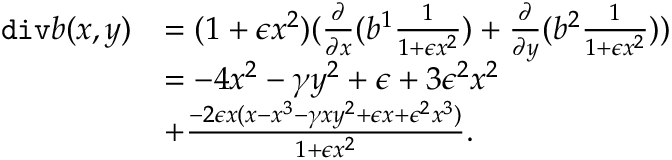Convert formula to latex. <formula><loc_0><loc_0><loc_500><loc_500>\begin{array} { r l } { d i v b ( x , y ) } & { = ( 1 + \epsilon x ^ { 2 } ) ( \frac { \partial } { \partial { x } } ( b ^ { 1 } \frac { 1 } { 1 + \epsilon x ^ { 2 } } ) + \frac { \partial } { \partial { y } } ( b ^ { 2 } \frac { 1 } { 1 + \epsilon x ^ { 2 } } ) ) } \\ & { = - 4 x ^ { 2 } - \gamma y ^ { 2 } + \epsilon + 3 \epsilon ^ { 2 } x ^ { 2 } } \\ & { + \frac { - 2 \epsilon x ( x - x ^ { 3 } - \gamma x y ^ { 2 } + \epsilon x + \epsilon ^ { 2 } x ^ { 3 } ) } { 1 + \epsilon x ^ { 2 } } . } \end{array}</formula> 